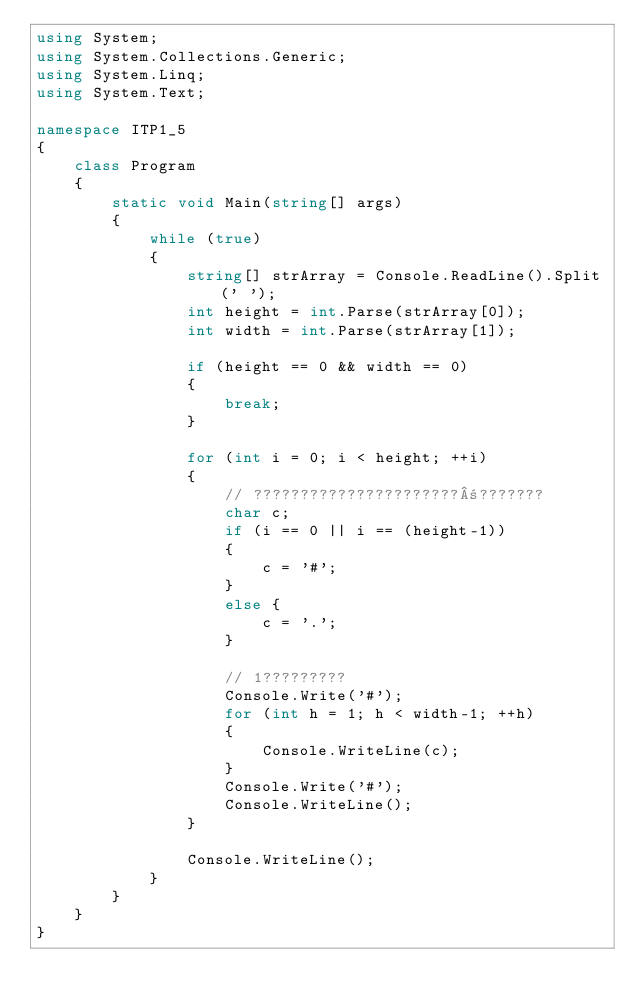Convert code to text. <code><loc_0><loc_0><loc_500><loc_500><_C#_>using System;
using System.Collections.Generic;
using System.Linq;
using System.Text;

namespace ITP1_5
{
    class Program
    {
        static void Main(string[] args)
        {
            while (true)
            {
                string[] strArray = Console.ReadLine().Split(' ');
                int height = int.Parse(strArray[0]);
                int width = int.Parse(strArray[1]);

                if (height == 0 && width == 0)
                {
                    break;
                }

                for (int i = 0; i < height; ++i)
                {
                    // ??????????????????????±???????
                    char c;
                    if (i == 0 || i == (height-1)) 
                    {
                        c = '#';
                    }
                    else {
                        c = '.';
                    }

                    // 1?????????
                    Console.Write('#');
                    for (int h = 1; h < width-1; ++h)
                    {
                        Console.WriteLine(c);
                    }
                    Console.Write('#');
                    Console.WriteLine();
                }

                Console.WriteLine();
            }
        }
    }
}</code> 